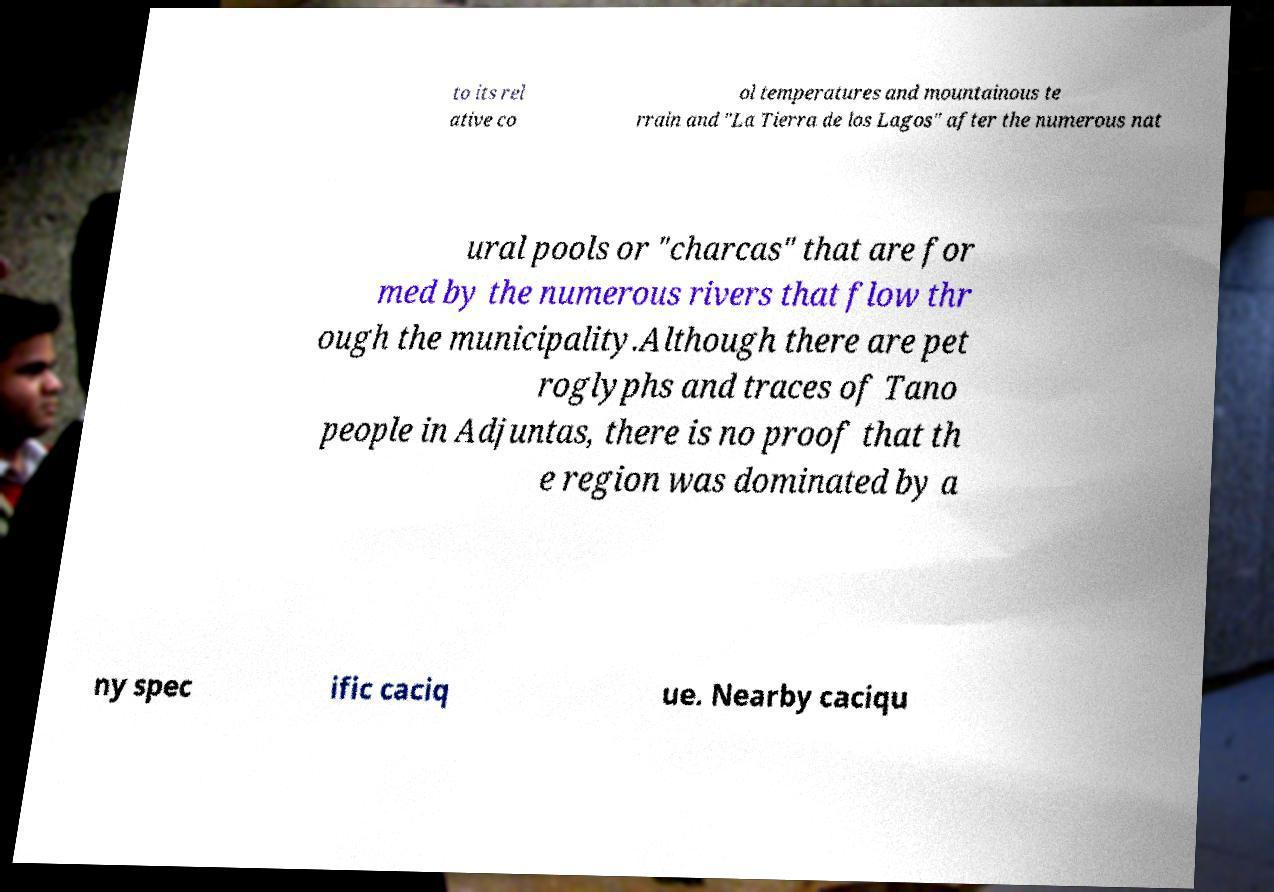What messages or text are displayed in this image? I need them in a readable, typed format. to its rel ative co ol temperatures and mountainous te rrain and "La Tierra de los Lagos" after the numerous nat ural pools or "charcas" that are for med by the numerous rivers that flow thr ough the municipality.Although there are pet roglyphs and traces of Tano people in Adjuntas, there is no proof that th e region was dominated by a ny spec ific caciq ue. Nearby caciqu 